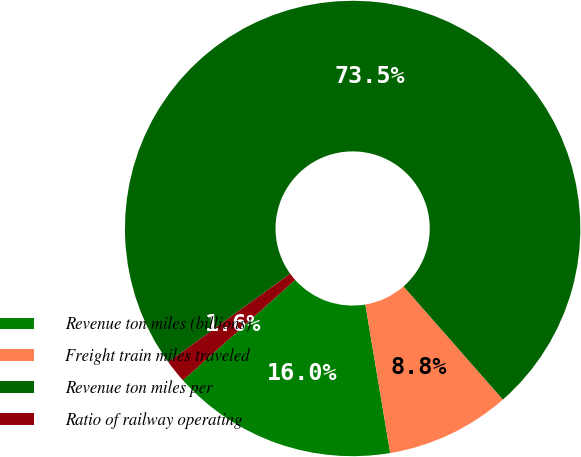Convert chart. <chart><loc_0><loc_0><loc_500><loc_500><pie_chart><fcel>Revenue ton miles (billions)<fcel>Freight train miles traveled<fcel>Revenue ton miles per<fcel>Ratio of railway operating<nl><fcel>16.02%<fcel>8.83%<fcel>73.51%<fcel>1.64%<nl></chart> 